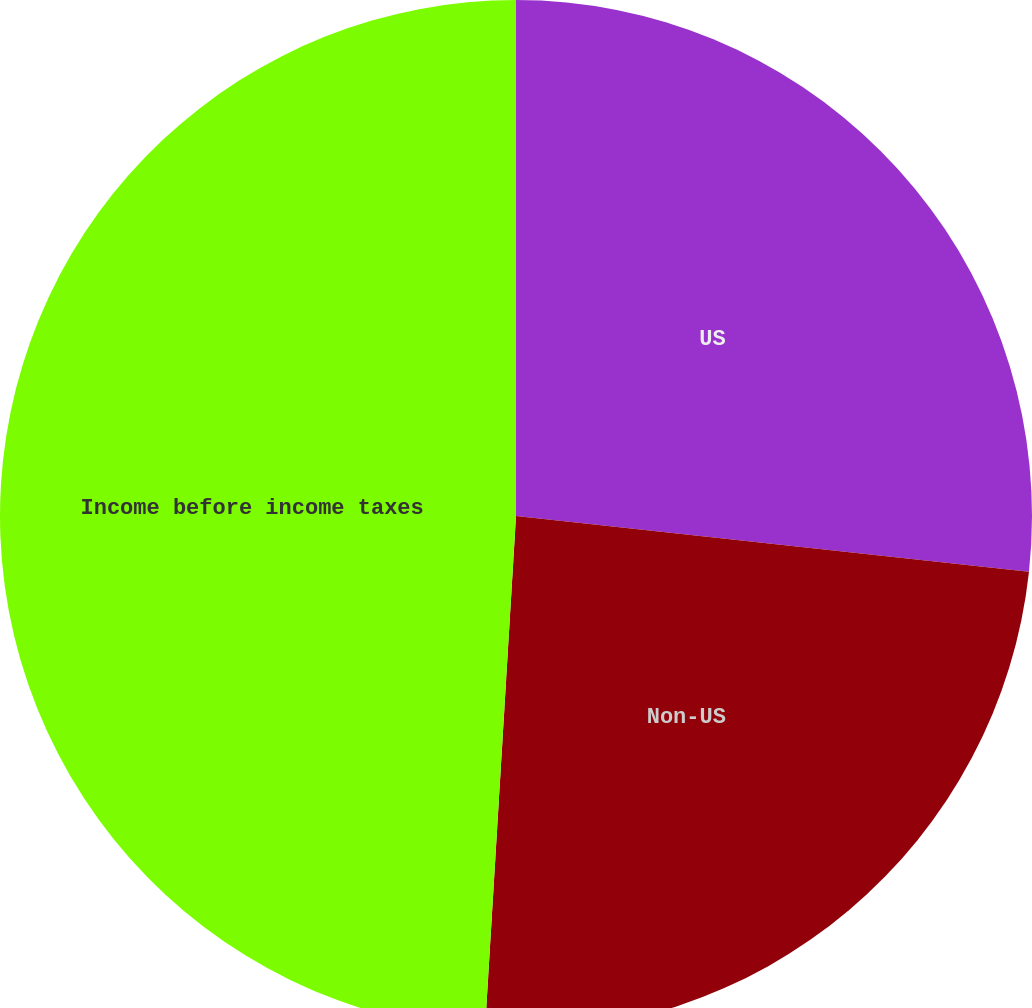Convert chart to OTSL. <chart><loc_0><loc_0><loc_500><loc_500><pie_chart><fcel>US<fcel>Non-US<fcel>Income before income taxes<nl><fcel>26.72%<fcel>24.24%<fcel>49.04%<nl></chart> 